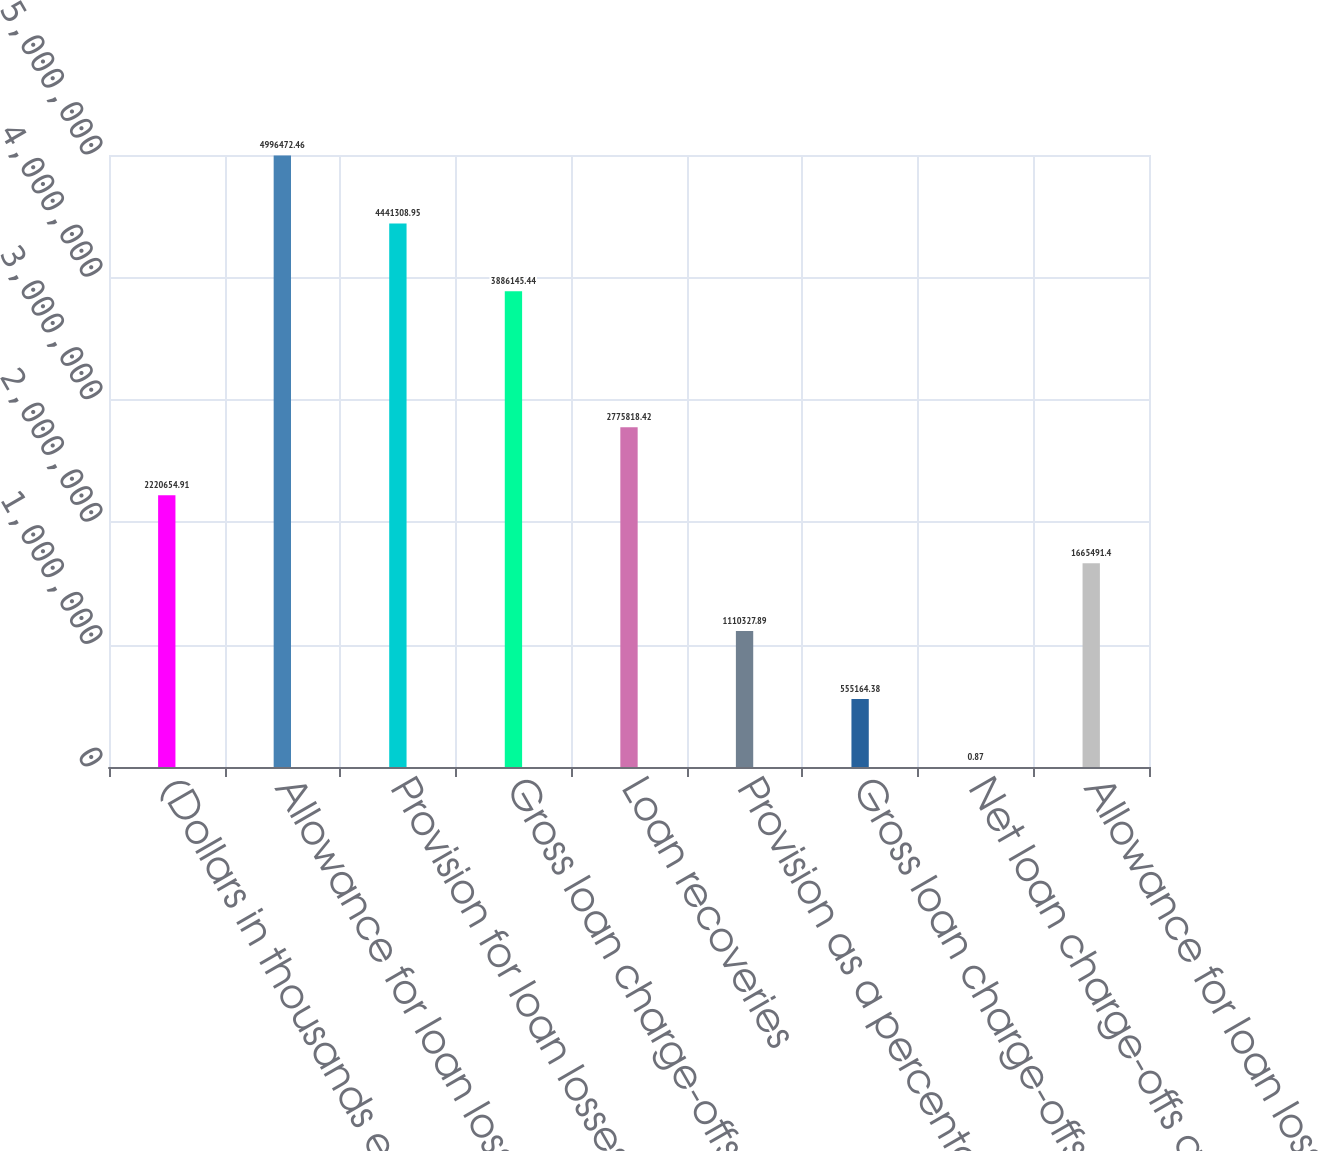<chart> <loc_0><loc_0><loc_500><loc_500><bar_chart><fcel>(Dollars in thousands except<fcel>Allowance for loan losses<fcel>Provision for loan losses<fcel>Gross loan charge-offs<fcel>Loan recoveries<fcel>Provision as a percentage of<fcel>Gross loan charge-offs as a<fcel>Net loan charge-offs as a<fcel>Allowance for loan losses as a<nl><fcel>2.22065e+06<fcel>4.99647e+06<fcel>4.44131e+06<fcel>3.88615e+06<fcel>2.77582e+06<fcel>1.11033e+06<fcel>555164<fcel>0.87<fcel>1.66549e+06<nl></chart> 